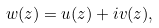<formula> <loc_0><loc_0><loc_500><loc_500>w ( z ) = u ( z ) + i v ( z ) ,</formula> 